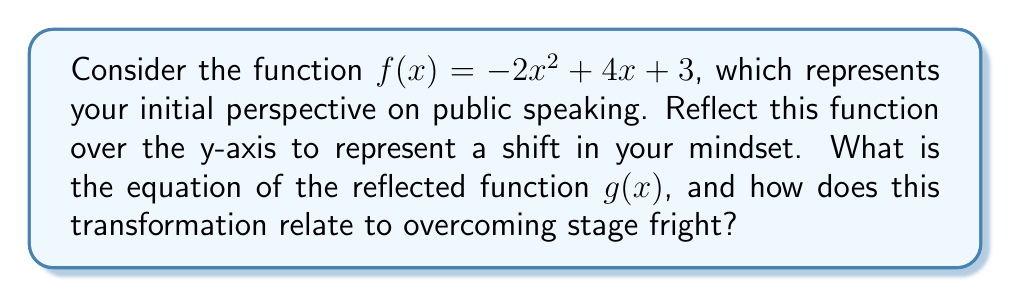Solve this math problem. 1) To reflect a function over the y-axis, we replace every $x$ with $-x$ in the original function. This gives us:

   $g(x) = -2(-x)^2 + 4(-x) + 3$

2) Simplify the squared term:
   $g(x) = -2x^2 - 4x + 3$

3) The transformation from $f(x)$ to $g(x)$ can be interpreted as follows:

   a) The parabola's shape (determined by $-2x^2$) remains unchanged, symbolizing that the core of public speaking remains the same.

   b) The linear term changes from $4x$ to $-4x$, representing a shift in perspective. This could symbolize viewing challenges as opportunities for growth.

   c) The constant term (3) stays the same, suggesting that your inherent abilities remain constant.

4) Overcoming stage fright relates to this transformation:
   - Just as the function is reflected but maintains its basic shape, you can change your perspective on public speaking while still being yourself.
   - The symmetry of the reflection suggests that positive and negative aspects can be balanced, helping to reduce anxiety.
   - The process of transforming the function mirrors the process of transforming one's mindset about public speaking.
Answer: $g(x) = -2x^2 - 4x + 3$ 